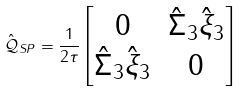Convert formula to latex. <formula><loc_0><loc_0><loc_500><loc_500>\hat { \mathcal { Q } } _ { S P } = \frac { 1 } { 2 \tau } \begin{bmatrix} 0 & \hat { \Sigma } _ { 3 } \hat { \xi } _ { 3 } \\ \hat { \Sigma } _ { 3 } \hat { \xi } _ { 3 } & 0 \end{bmatrix}</formula> 